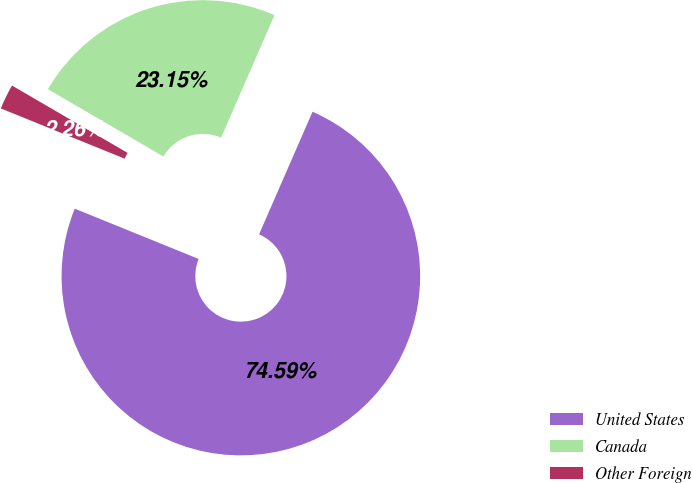Convert chart to OTSL. <chart><loc_0><loc_0><loc_500><loc_500><pie_chart><fcel>United States<fcel>Canada<fcel>Other Foreign<nl><fcel>74.59%<fcel>23.15%<fcel>2.26%<nl></chart> 